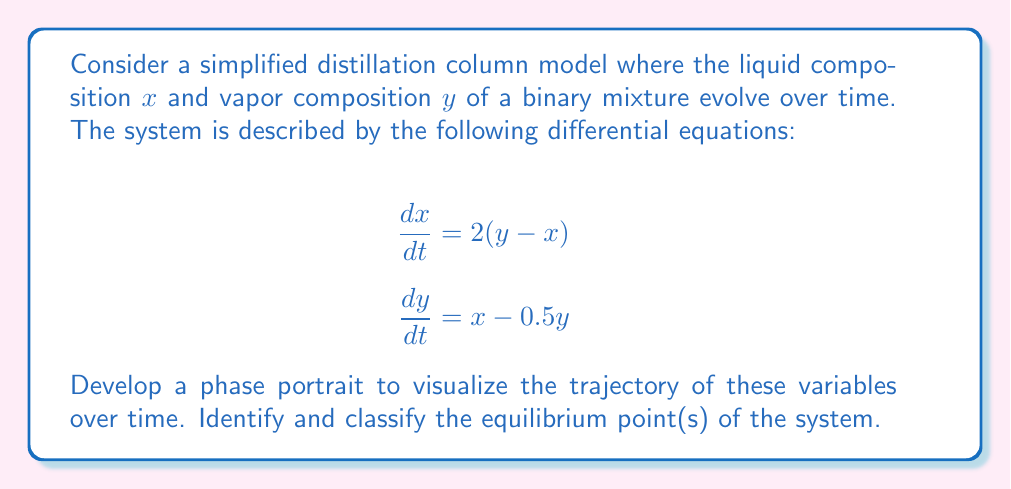Show me your answer to this math problem. To develop a phase portrait and analyze the equilibrium points, we'll follow these steps:

1) Find the equilibrium point(s):
   Set $\frac{dx}{dt} = 0$ and $\frac{dy}{dt} = 0$:
   
   $2(y - x) = 0$ implies $y = x$
   $x - 0.5y = 0$ implies $x = 0.5y$
   
   Solving these simultaneously: $x = y = 0$
   
   The equilibrium point is (0, 0).

2) Linearize the system around the equilibrium point:
   The Jacobian matrix at (0, 0) is:
   
   $$J = \begin{bmatrix}
   \frac{\partial}{\partial x}(2(y-x)) & \frac{\partial}{\partial y}(2(y-x)) \\
   \frac{\partial}{\partial x}(x-0.5y) & \frac{\partial}{\partial y}(x-0.5y)
   \end{bmatrix} = \begin{bmatrix}
   -2 & 2 \\
   1 & -0.5
   \end{bmatrix}$$

3) Find the eigenvalues of the Jacobian:
   $\det(J - \lambda I) = 0$
   
   $$\begin{vmatrix}
   -2-\lambda & 2 \\
   1 & -0.5-\lambda
   \end{vmatrix} = 0$$
   
   $\lambda^2 + 2.5\lambda + 0 = 0$
   
   $\lambda_1 = 0, \lambda_2 = -2.5$

4) Classify the equilibrium point:
   With one zero eigenvalue and one negative eigenvalue, the equilibrium point is a degenerate node.

5) Sketch the phase portrait:
   [asy]
   import graph;
   size(200);
   
   xaxis("x", -2, 2, Arrow);
   yaxis("y", -2, 2, Arrow);
   
   void vector(real x, real y) {
     draw((x,y)--(x+0.2*(2*(y-x)),y+0.2*(x-0.5*y)), Arrow);
   }
   
   for(int i = -8; i <= 8; ++i) {
     for(int j = -8; j <= 8; ++j) {
       vector(0.25*i, 0.25*j);
     }
   }
   
   dot((0,0));
   label("(0,0)", (0,0), SE);
   [/asy]

The phase portrait shows that trajectories approach the x-axis (y=0) as time increases, indicating that the vapor composition tends to zero faster than the liquid composition. The equilibrium point (0,0) acts as an attractor, but trajectories approach it tangent to the x-axis due to the zero eigenvalue.
Answer: Degenerate node at (0,0); trajectories approach x-axis as $t \to \infty$. 